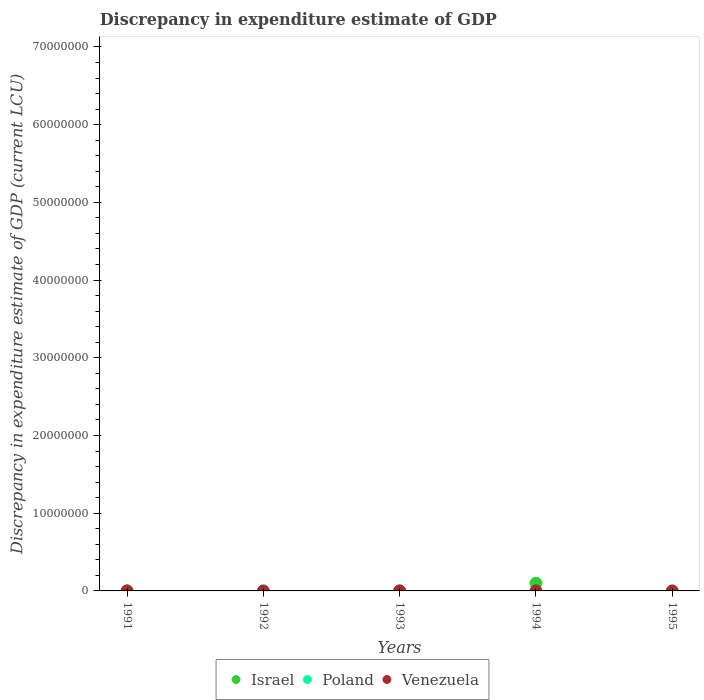How many different coloured dotlines are there?
Offer a very short reply. 2. Is the number of dotlines equal to the number of legend labels?
Offer a very short reply. No. What is the discrepancy in expenditure estimate of GDP in Israel in 1991?
Ensure brevity in your answer.  4100. Across all years, what is the maximum discrepancy in expenditure estimate of GDP in Israel?
Provide a succinct answer. 9.95e+05. Across all years, what is the minimum discrepancy in expenditure estimate of GDP in Venezuela?
Offer a very short reply. 0. In which year was the discrepancy in expenditure estimate of GDP in Venezuela maximum?
Offer a terse response. 1992. What is the total discrepancy in expenditure estimate of GDP in Venezuela in the graph?
Offer a terse response. 0. What is the difference between the discrepancy in expenditure estimate of GDP in Venezuela in 1992 and that in 1994?
Provide a succinct answer. 0. What is the difference between the discrepancy in expenditure estimate of GDP in Israel in 1993 and the discrepancy in expenditure estimate of GDP in Venezuela in 1991?
Your response must be concise. 0. What is the average discrepancy in expenditure estimate of GDP in Venezuela per year?
Make the answer very short. 4.007e-5. In the year 1994, what is the difference between the discrepancy in expenditure estimate of GDP in Venezuela and discrepancy in expenditure estimate of GDP in Israel?
Provide a succinct answer. -9.95e+05. In how many years, is the discrepancy in expenditure estimate of GDP in Poland greater than 64000000 LCU?
Offer a very short reply. 0. What is the difference between the highest and the lowest discrepancy in expenditure estimate of GDP in Israel?
Ensure brevity in your answer.  9.95e+05. In how many years, is the discrepancy in expenditure estimate of GDP in Israel greater than the average discrepancy in expenditure estimate of GDP in Israel taken over all years?
Keep it short and to the point. 1. Does the discrepancy in expenditure estimate of GDP in Israel monotonically increase over the years?
Keep it short and to the point. No. Is the discrepancy in expenditure estimate of GDP in Venezuela strictly less than the discrepancy in expenditure estimate of GDP in Israel over the years?
Offer a very short reply. No. What is the difference between two consecutive major ticks on the Y-axis?
Your answer should be very brief. 1.00e+07. Does the graph contain grids?
Keep it short and to the point. No. How many legend labels are there?
Provide a succinct answer. 3. How are the legend labels stacked?
Provide a succinct answer. Horizontal. What is the title of the graph?
Keep it short and to the point. Discrepancy in expenditure estimate of GDP. Does "Sao Tome and Principe" appear as one of the legend labels in the graph?
Make the answer very short. No. What is the label or title of the Y-axis?
Your response must be concise. Discrepancy in expenditure estimate of GDP (current LCU). What is the Discrepancy in expenditure estimate of GDP (current LCU) of Israel in 1991?
Provide a short and direct response. 4100. What is the Discrepancy in expenditure estimate of GDP (current LCU) in Venezuela in 1991?
Your answer should be compact. 0. What is the Discrepancy in expenditure estimate of GDP (current LCU) in Israel in 1992?
Provide a succinct answer. 0. What is the Discrepancy in expenditure estimate of GDP (current LCU) in Venezuela in 1992?
Your response must be concise. 0. What is the Discrepancy in expenditure estimate of GDP (current LCU) of Israel in 1993?
Make the answer very short. 0. What is the Discrepancy in expenditure estimate of GDP (current LCU) of Poland in 1993?
Ensure brevity in your answer.  0. What is the Discrepancy in expenditure estimate of GDP (current LCU) in Venezuela in 1993?
Offer a terse response. 0. What is the Discrepancy in expenditure estimate of GDP (current LCU) in Israel in 1994?
Your answer should be compact. 9.95e+05. What is the Discrepancy in expenditure estimate of GDP (current LCU) of Venezuela in 1994?
Give a very brief answer. 5.4e-7. Across all years, what is the maximum Discrepancy in expenditure estimate of GDP (current LCU) of Israel?
Provide a short and direct response. 9.95e+05. Across all years, what is the maximum Discrepancy in expenditure estimate of GDP (current LCU) in Venezuela?
Provide a succinct answer. 0. What is the total Discrepancy in expenditure estimate of GDP (current LCU) of Israel in the graph?
Make the answer very short. 9.99e+05. What is the total Discrepancy in expenditure estimate of GDP (current LCU) in Venezuela in the graph?
Keep it short and to the point. 0. What is the difference between the Discrepancy in expenditure estimate of GDP (current LCU) of Israel in 1991 and that in 1994?
Make the answer very short. -9.91e+05. What is the difference between the Discrepancy in expenditure estimate of GDP (current LCU) in Israel in 1991 and the Discrepancy in expenditure estimate of GDP (current LCU) in Venezuela in 1992?
Provide a succinct answer. 4100. What is the difference between the Discrepancy in expenditure estimate of GDP (current LCU) in Israel in 1991 and the Discrepancy in expenditure estimate of GDP (current LCU) in Venezuela in 1994?
Offer a very short reply. 4100. What is the average Discrepancy in expenditure estimate of GDP (current LCU) in Israel per year?
Your response must be concise. 2.00e+05. What is the average Discrepancy in expenditure estimate of GDP (current LCU) in Poland per year?
Give a very brief answer. 0. What is the average Discrepancy in expenditure estimate of GDP (current LCU) of Venezuela per year?
Give a very brief answer. 0. In the year 1994, what is the difference between the Discrepancy in expenditure estimate of GDP (current LCU) of Israel and Discrepancy in expenditure estimate of GDP (current LCU) of Venezuela?
Provide a succinct answer. 9.95e+05. What is the ratio of the Discrepancy in expenditure estimate of GDP (current LCU) of Israel in 1991 to that in 1994?
Make the answer very short. 0. What is the ratio of the Discrepancy in expenditure estimate of GDP (current LCU) in Venezuela in 1992 to that in 1994?
Ensure brevity in your answer.  370.02. What is the difference between the highest and the lowest Discrepancy in expenditure estimate of GDP (current LCU) of Israel?
Offer a terse response. 9.95e+05. 